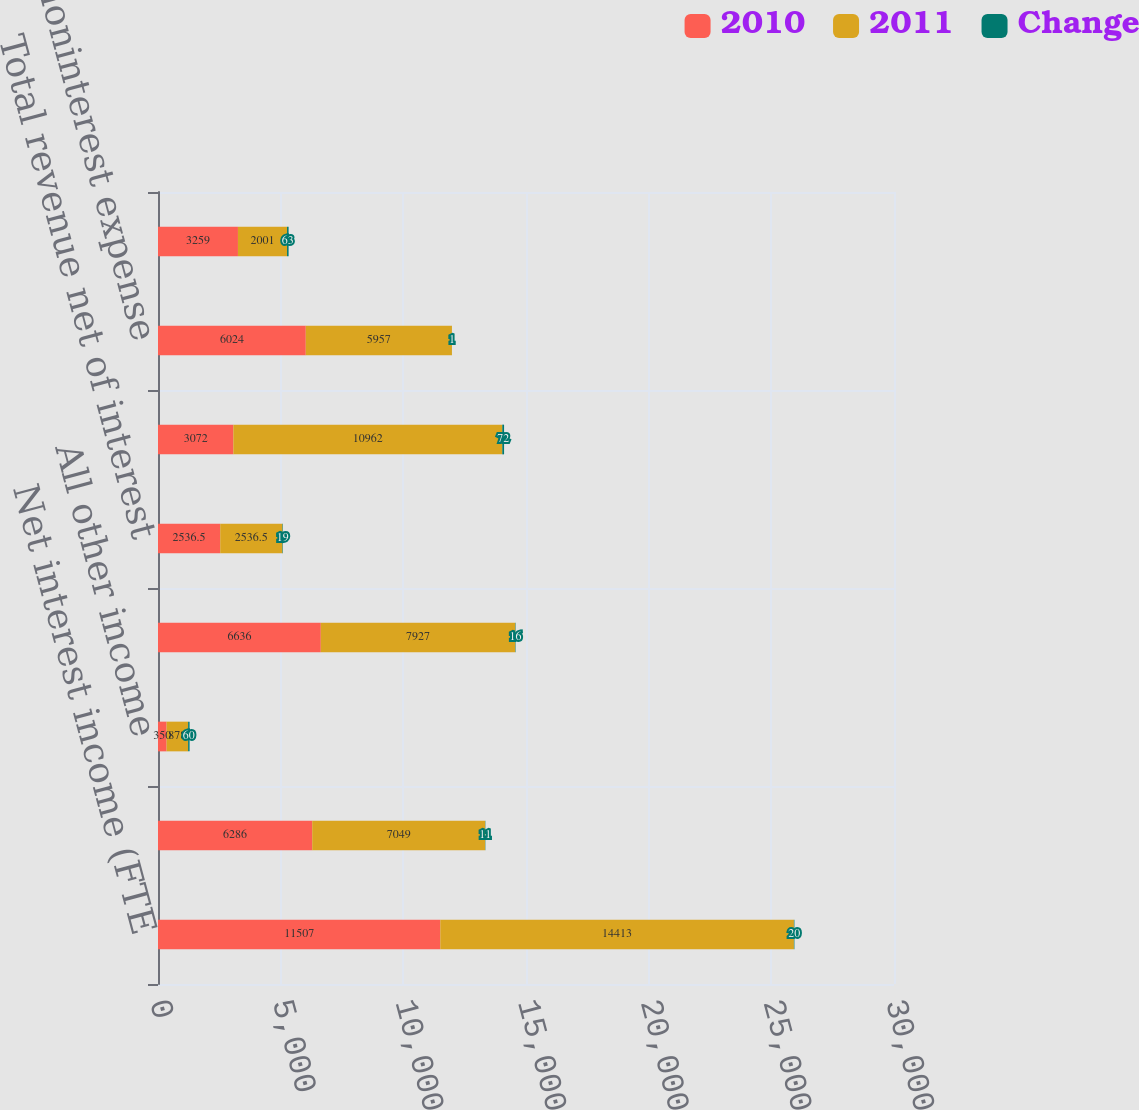Convert chart. <chart><loc_0><loc_0><loc_500><loc_500><stacked_bar_chart><ecel><fcel>Net interest income (FTE<fcel>Card income<fcel>All other income<fcel>Total noninterest income<fcel>Total revenue net of interest<fcel>Provision for credit losses<fcel>All other noninterest expense<fcel>Income tax expense (FTE basis)<nl><fcel>2010<fcel>11507<fcel>6286<fcel>350<fcel>6636<fcel>2536.5<fcel>3072<fcel>6024<fcel>3259<nl><fcel>2011<fcel>14413<fcel>7049<fcel>878<fcel>7927<fcel>2536.5<fcel>10962<fcel>5957<fcel>2001<nl><fcel>Change<fcel>20<fcel>11<fcel>60<fcel>16<fcel>19<fcel>72<fcel>1<fcel>63<nl></chart> 